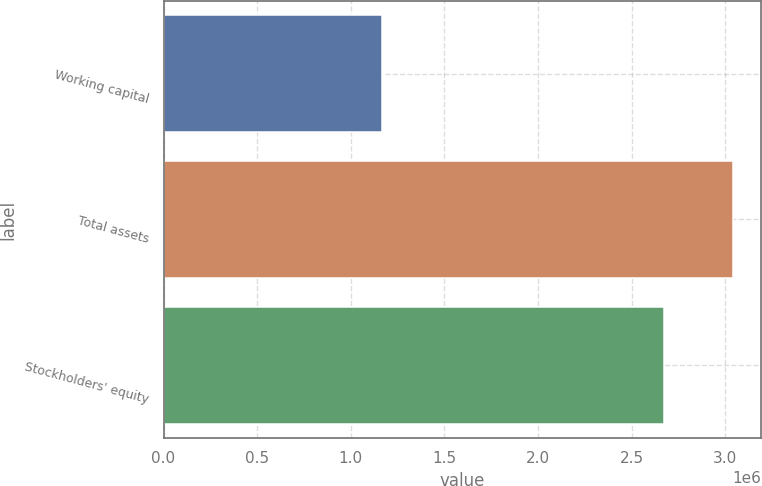Convert chart. <chart><loc_0><loc_0><loc_500><loc_500><bar_chart><fcel>Working capital<fcel>Total assets<fcel>Stockholders' equity<nl><fcel>1.16797e+06<fcel>3.0392e+06<fcel>2.67351e+06<nl></chart> 